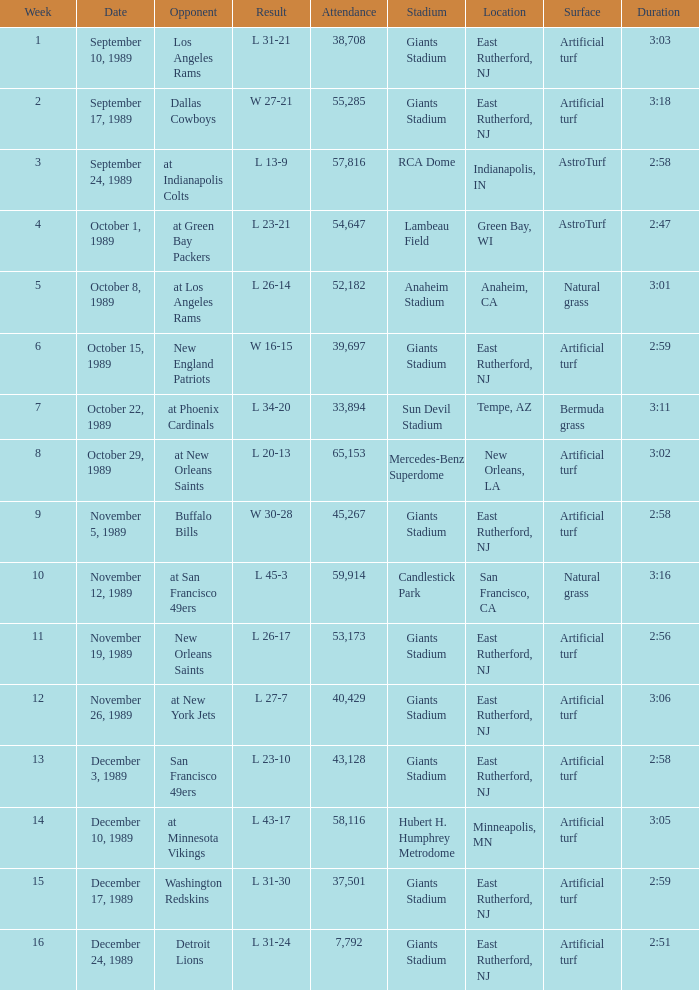For what week was the attendance 40,429? 12.0. 